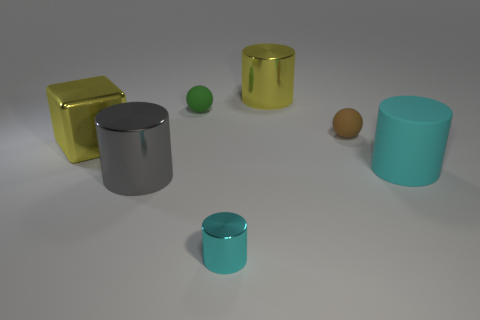Is there an indication of how these items might be used? Without additional context, their use is ambiguous. However, the cylindrical objects could serve as containers, vases, or decorative pieces, while the spheres might be ornamental or used in games. The cube-like golden object stands out with its distinct shape, suggesting a decorative function or perhaps being part of something else, like a piece of art or a component in a larger mechanical setup. 